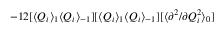Convert formula to latex. <formula><loc_0><loc_0><loc_500><loc_500>- 1 2 [ \langle Q _ { i } \rangle _ { 1 } \langle Q _ { i } \rangle _ { - 1 } ] [ \langle Q _ { i } \rangle _ { 1 } \langle Q _ { i } \rangle _ { - 1 } ] [ \langle { \partial ^ { 2 } } / { \partial Q _ { i } ^ { 2 } } \rangle _ { 0 } ]</formula> 